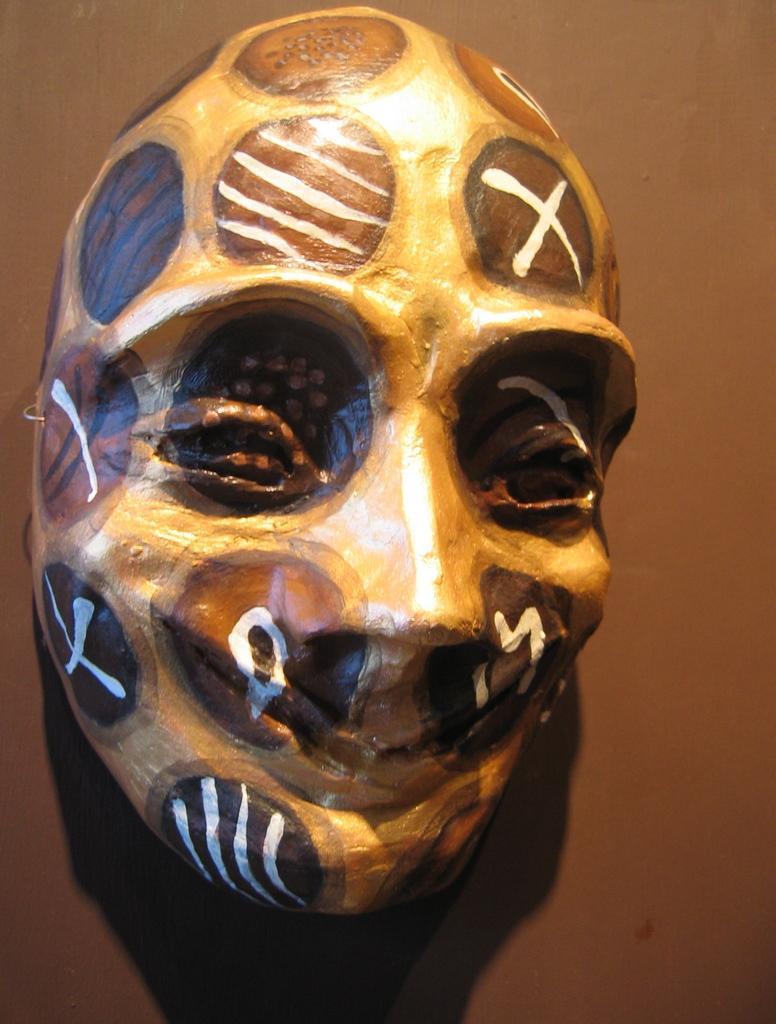Please provide a concise description of this image. In this picture i can see a mask on a surface. 